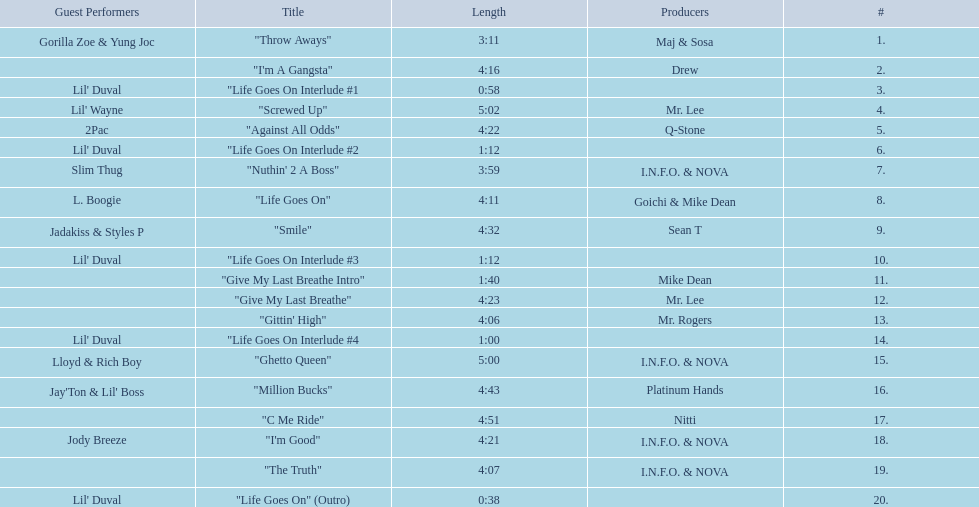Which tracks are longer than 4.00? "I'm A Gangsta", "Screwed Up", "Against All Odds", "Life Goes On", "Smile", "Give My Last Breathe", "Gittin' High", "Ghetto Queen", "Million Bucks", "C Me Ride", "I'm Good", "The Truth". Of those, which tracks are longer than 4.30? "Screwed Up", "Smile", "Ghetto Queen", "Million Bucks", "C Me Ride". Of those, which tracks are 5.00 or longer? "Screwed Up", "Ghetto Queen". Of those, which one is the longest? "Screwed Up". How long is that track? 5:02. 